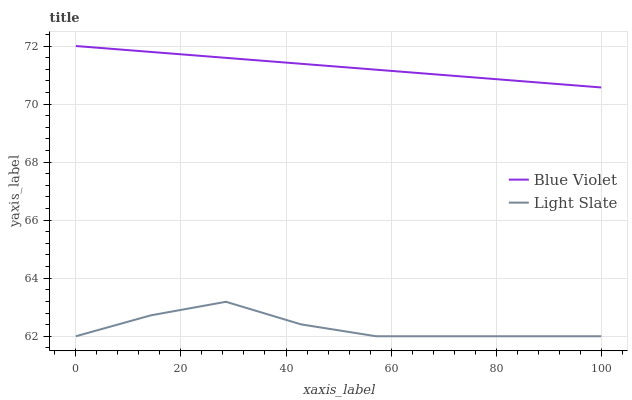Does Light Slate have the minimum area under the curve?
Answer yes or no. Yes. Does Blue Violet have the maximum area under the curve?
Answer yes or no. Yes. Does Blue Violet have the minimum area under the curve?
Answer yes or no. No. Is Blue Violet the smoothest?
Answer yes or no. Yes. Is Light Slate the roughest?
Answer yes or no. Yes. Is Blue Violet the roughest?
Answer yes or no. No. Does Light Slate have the lowest value?
Answer yes or no. Yes. Does Blue Violet have the lowest value?
Answer yes or no. No. Does Blue Violet have the highest value?
Answer yes or no. Yes. Is Light Slate less than Blue Violet?
Answer yes or no. Yes. Is Blue Violet greater than Light Slate?
Answer yes or no. Yes. Does Light Slate intersect Blue Violet?
Answer yes or no. No. 